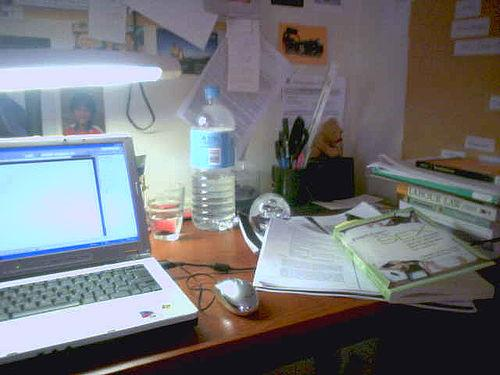What might sit in the glass?

Choices:
A) dentures
B) nothing
C) wine
D) pencils dentures 